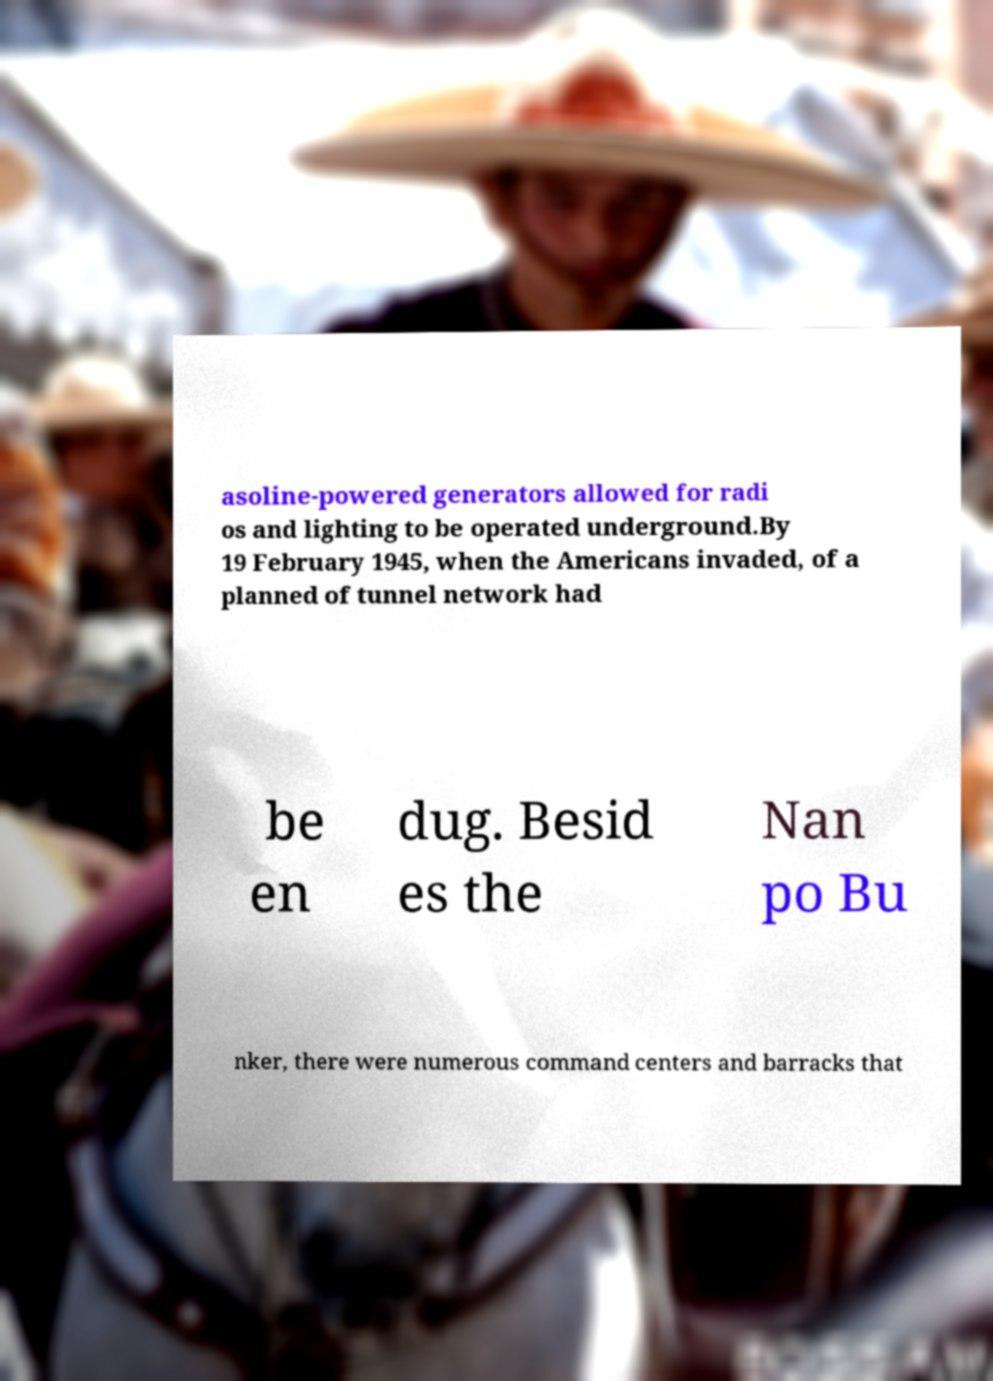Can you accurately transcribe the text from the provided image for me? asoline-powered generators allowed for radi os and lighting to be operated underground.By 19 February 1945, when the Americans invaded, of a planned of tunnel network had be en dug. Besid es the Nan po Bu nker, there were numerous command centers and barracks that 